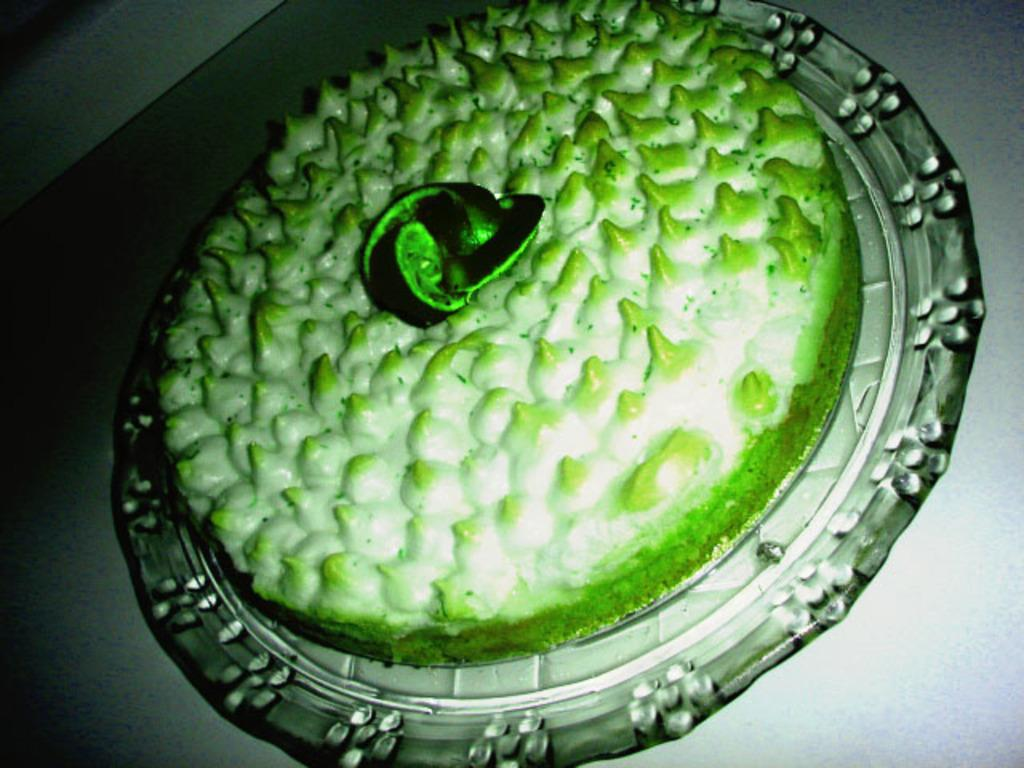What is the main object on the plate in the image? There is a cake on a plate in the image. Where is the plate with the cake located? The plate is on a surface in the image. What type of friction can be observed between the cake and the plate in the image? There is no indication of friction between the cake and the plate in the image, as it is a static scene. 